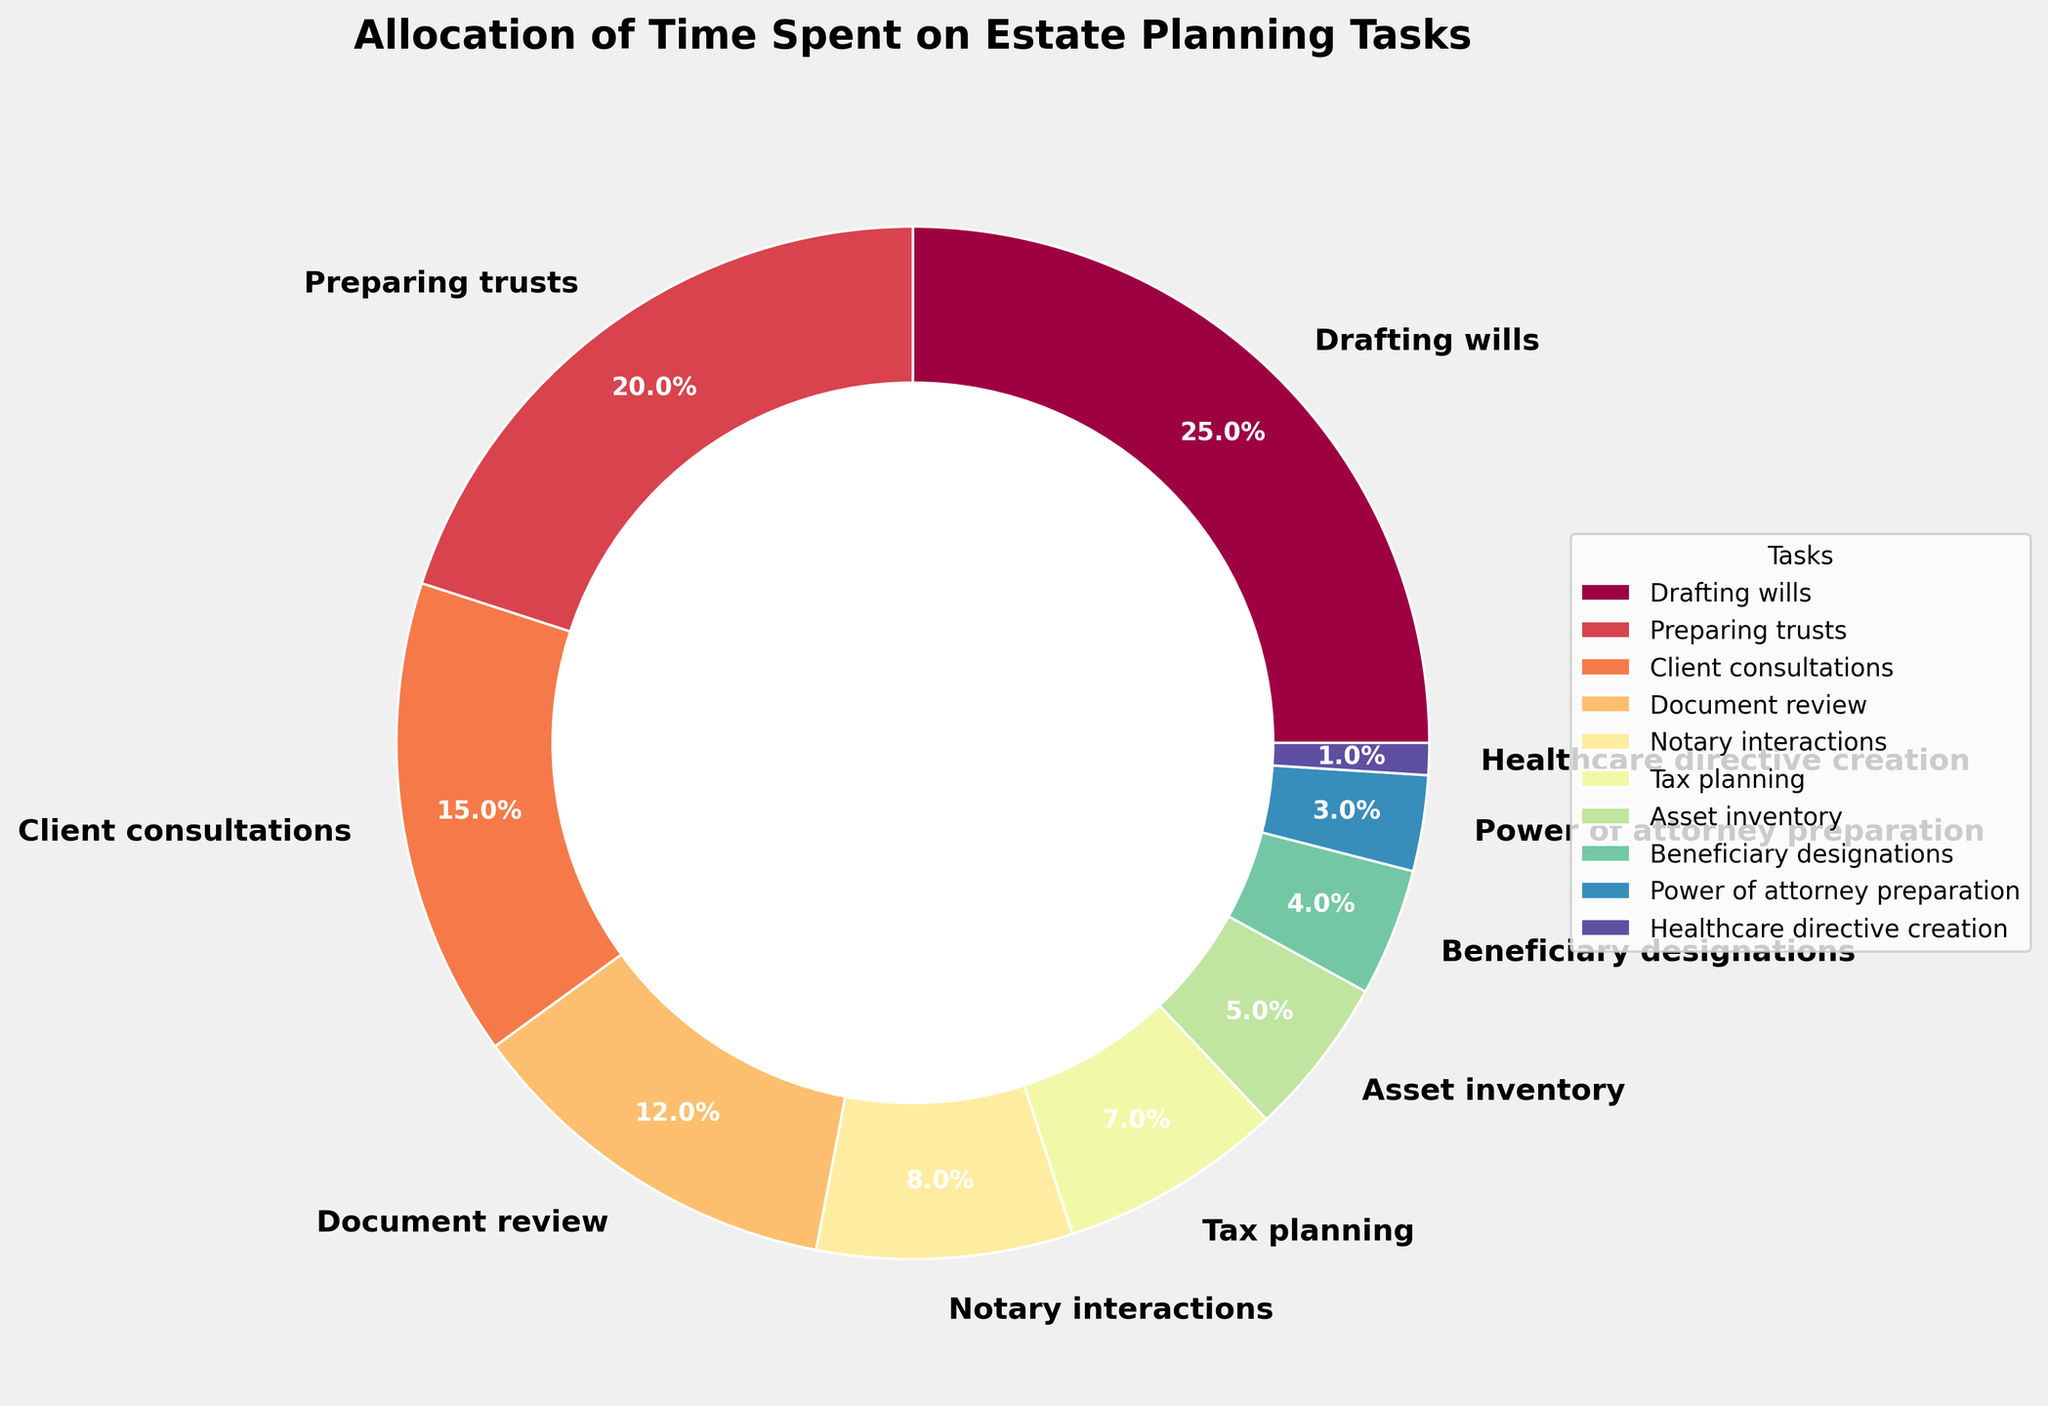What task requires the most time? The task that requires the most time can be found by identifying the section of the pie chart with the largest percentage. This is "Drafting wills" with 25%.
Answer: Drafting wills Which two tasks combined account for the highest percentage? To find the two tasks that combined account for the highest percentage, look for the two largest sections of the pie chart. These are "Drafting wills" (25%) and "Preparing trusts" (20%), which together account for 45%.
Answer: Drafting wills and Preparing trusts How much more time is spent on Client consultations compared to Notary interactions? To determine this, find the percentage of time spent on Client consultations (15%) and Notary interactions (8%), and subtract the smaller percentage from the larger: 15% - 8% = 7%.
Answer: 7% Which task has the smallest allocation of time? The task with the smallest allocation of time is the smallest section of the pie chart. This is "Healthcare directive creation" with 1%.
Answer: Healthcare directive creation What is the combined percentage of time spent on Tax planning and Asset inventory? Find the percentages of time spent on Tax planning (7%) and Asset inventory (5%), and add them together: 7% + 5% = 12%.
Answer: 12% How does the time spent on Document review compare to Client consultations? To compare the time spent on these tasks, find their percentages: Document review is 12% and Client consultations is 15%. Document review is 3% less than Client consultations.
Answer: Document review is 3% less How many tasks require less than 5% of the time? Count the sections of the pie chart that represent less than 5%. These tasks are Power of attorney preparation (3%) and Healthcare directive creation (1%), totaling 2 tasks.
Answer: 2 